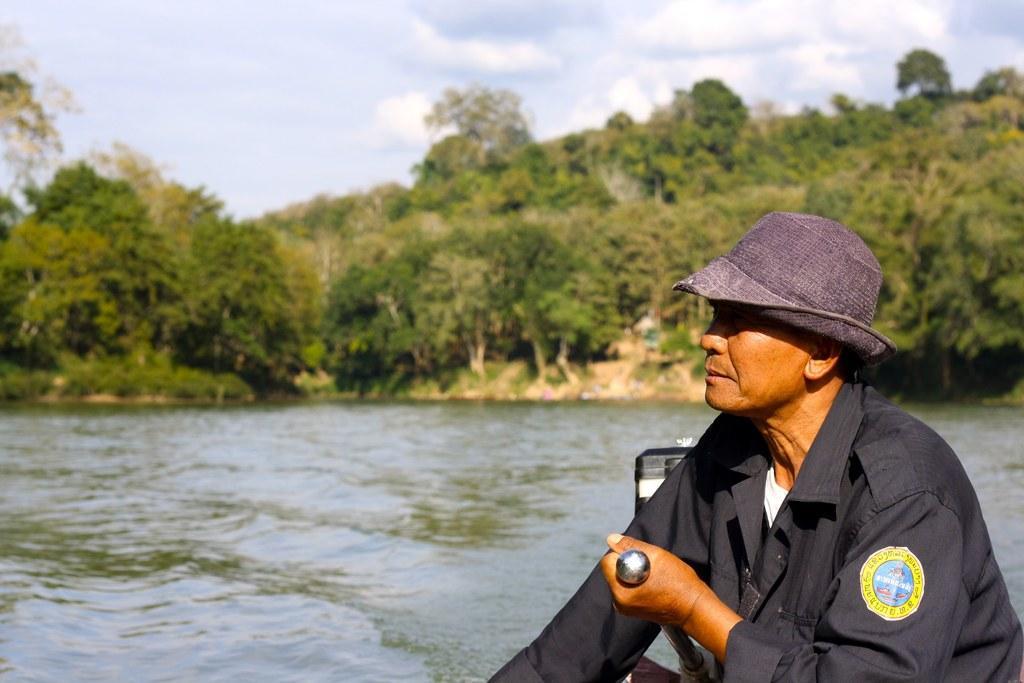Describe this image in one or two sentences. In this image I can see a person wearing black color dress is holding an object is sitting in a boat. In the background I can see the water, few trees and the sky. 